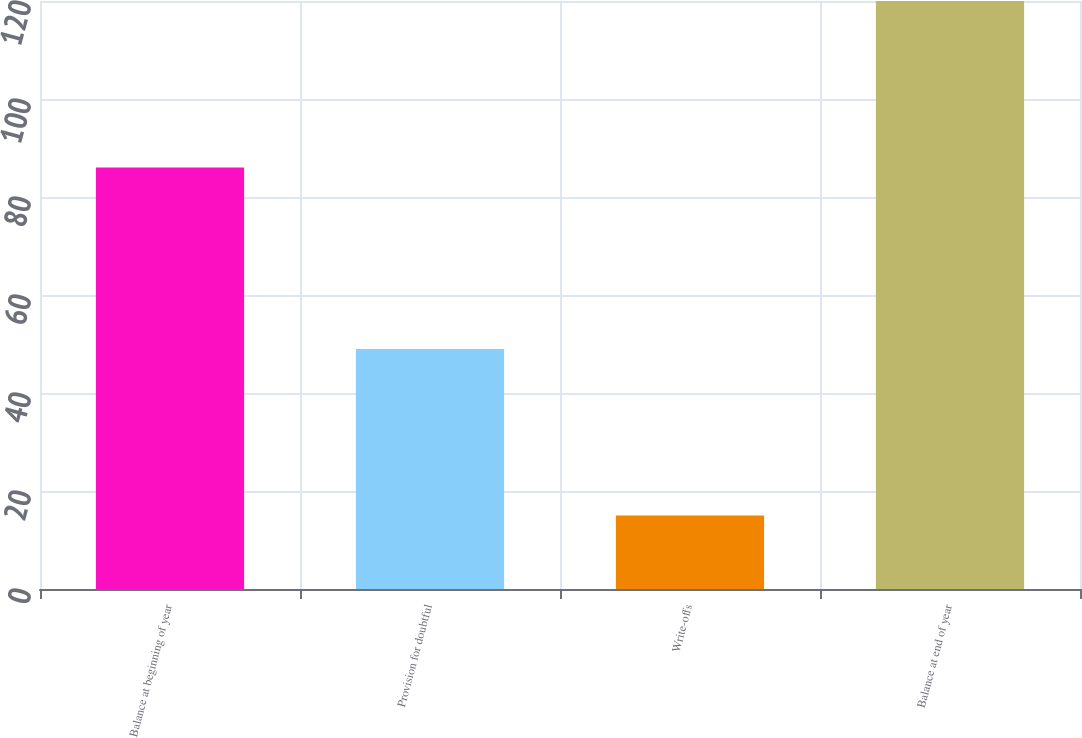Convert chart to OTSL. <chart><loc_0><loc_0><loc_500><loc_500><bar_chart><fcel>Balance at beginning of year<fcel>Provision for doubtful<fcel>Write-offs<fcel>Balance at end of year<nl><fcel>86<fcel>49<fcel>15<fcel>120<nl></chart> 